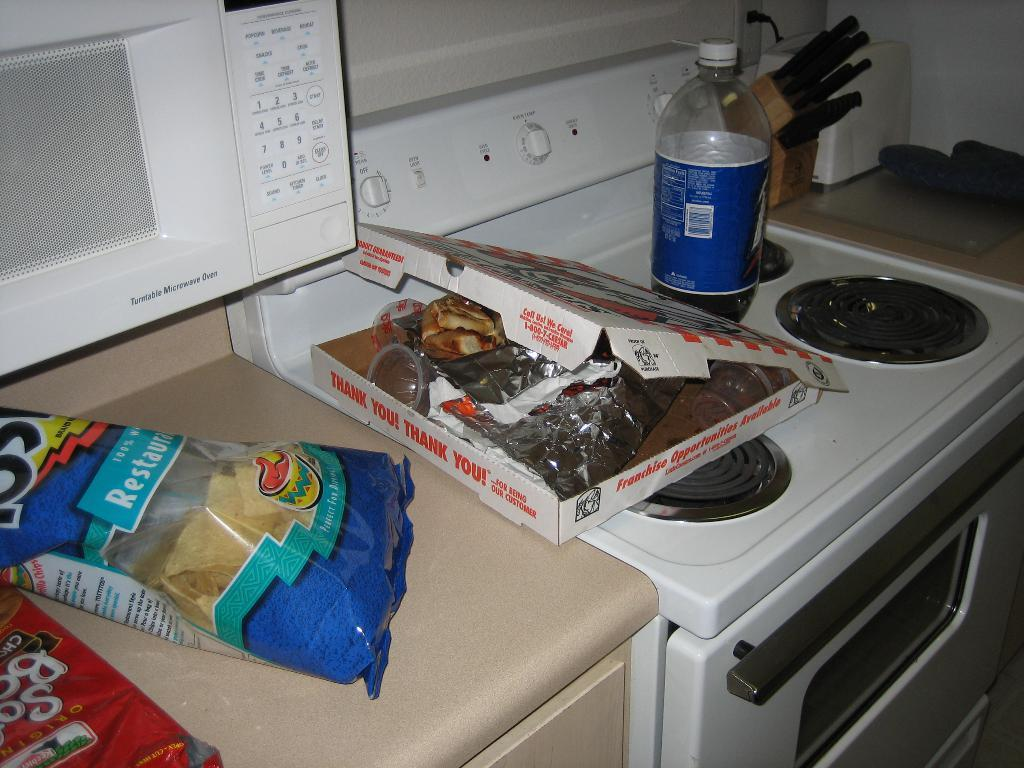<image>
Create a compact narrative representing the image presented. garbage on a kitchen counter including a pizza box that reads Thank You 